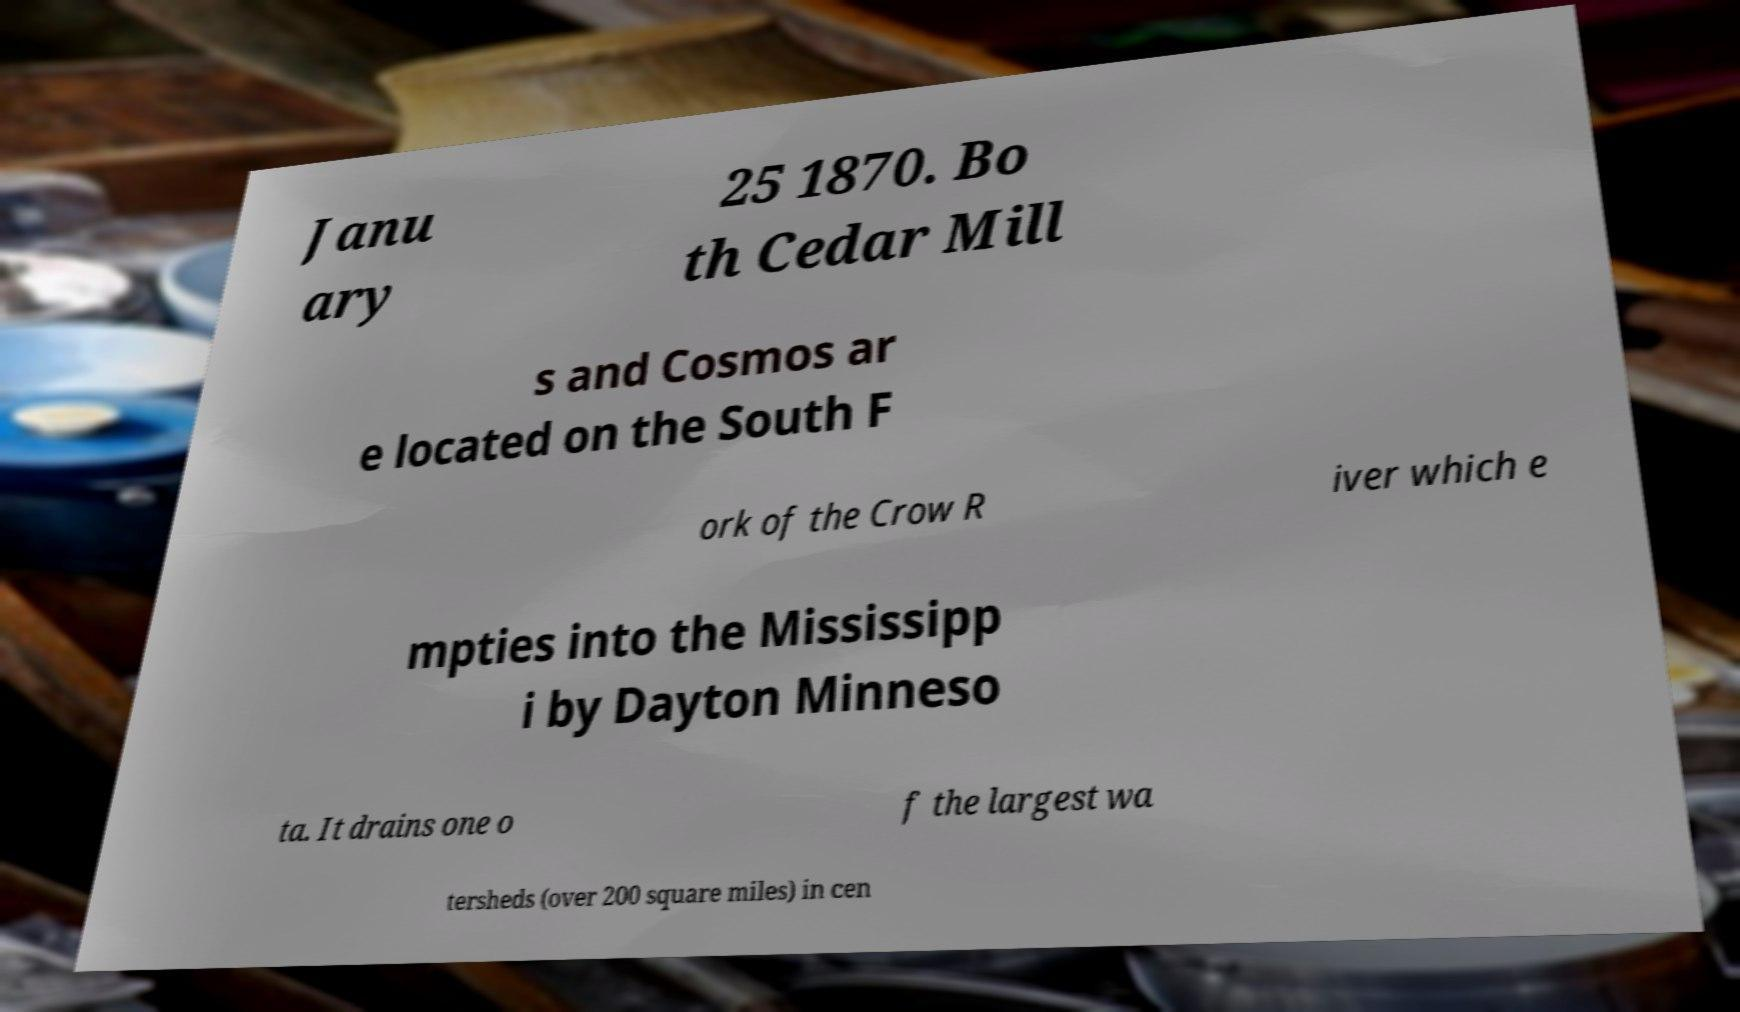For documentation purposes, I need the text within this image transcribed. Could you provide that? Janu ary 25 1870. Bo th Cedar Mill s and Cosmos ar e located on the South F ork of the Crow R iver which e mpties into the Mississipp i by Dayton Minneso ta. It drains one o f the largest wa tersheds (over 200 square miles) in cen 